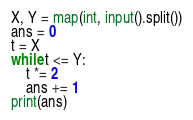<code> <loc_0><loc_0><loc_500><loc_500><_Python_>X, Y = map(int, input().split())
ans = 0
t = X
while t <= Y:
    t *= 2
    ans += 1
print(ans)
</code> 